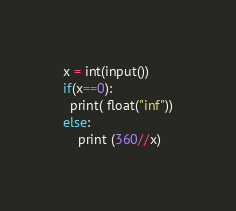Convert code to text. <code><loc_0><loc_0><loc_500><loc_500><_Python_>x = int(input())
if(x==0):
  print( float("inf"))
else:
    print (360//x)</code> 